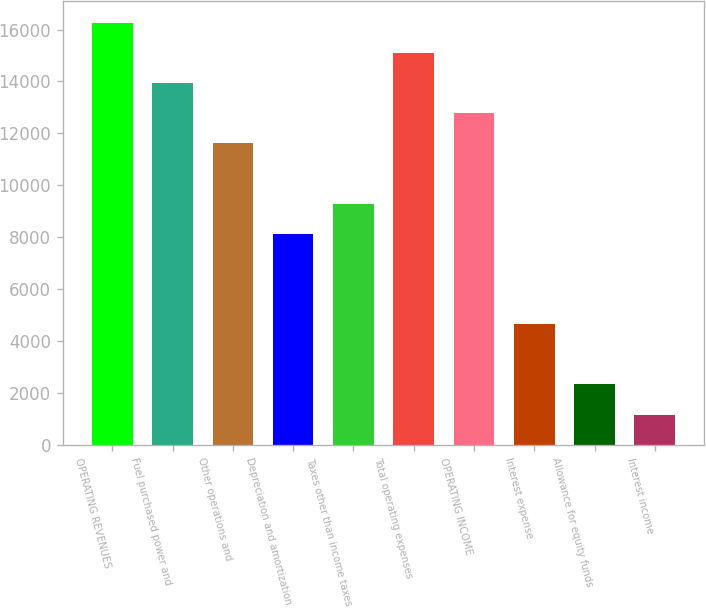Convert chart to OTSL. <chart><loc_0><loc_0><loc_500><loc_500><bar_chart><fcel>OPERATING REVENUES<fcel>Fuel purchased power and<fcel>Other operations and<fcel>Depreciation and amortization<fcel>Taxes other than income taxes<fcel>Total operating expenses<fcel>OPERATING INCOME<fcel>Interest expense<fcel>Allowance for equity funds<fcel>Interest income<nl><fcel>16266<fcel>13944<fcel>11622<fcel>8139<fcel>9300<fcel>15105<fcel>12783<fcel>4656<fcel>2334<fcel>1173<nl></chart> 